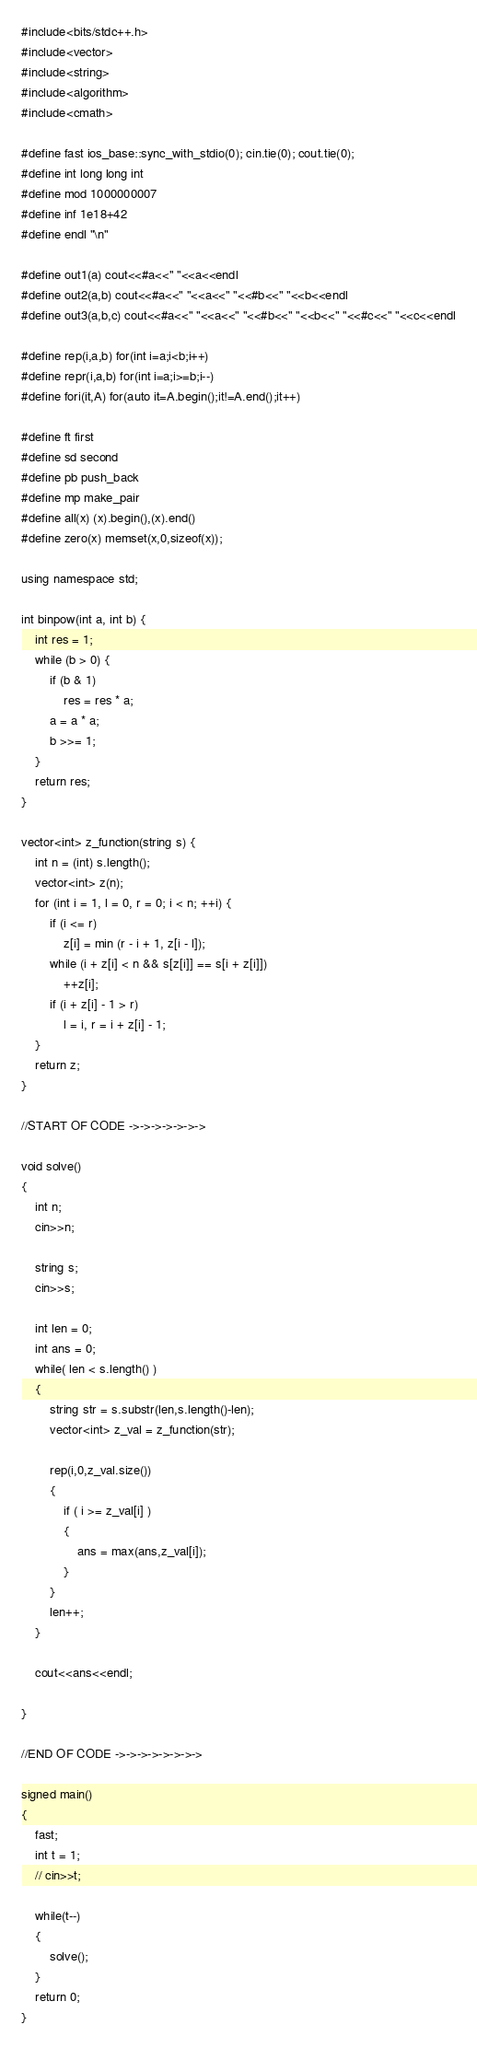<code> <loc_0><loc_0><loc_500><loc_500><_C_>#include<bits/stdc++.h>
#include<vector>
#include<string>
#include<algorithm>
#include<cmath>
 
#define fast ios_base::sync_with_stdio(0); cin.tie(0); cout.tie(0);
#define int long long int
#define mod 1000000007
#define inf 1e18+42
#define endl "\n"

#define out1(a) cout<<#a<<" "<<a<<endl
#define out2(a,b) cout<<#a<<" "<<a<<" "<<#b<<" "<<b<<endl
#define out3(a,b,c) cout<<#a<<" "<<a<<" "<<#b<<" "<<b<<" "<<#c<<" "<<c<<endl

#define rep(i,a,b) for(int i=a;i<b;i++)
#define repr(i,a,b) for(int i=a;i>=b;i--)
#define fori(it,A) for(auto it=A.begin();it!=A.end();it++)

#define ft first
#define sd second
#define pb push_back
#define mp make_pair
#define all(x) (x).begin(),(x).end()
#define zero(x) memset(x,0,sizeof(x));
 
using namespace std;

int binpow(int a, int b) {
    int res = 1;
    while (b > 0) {
        if (b & 1)
            res = res * a;
        a = a * a;
        b >>= 1;
    }
    return res;
}

vector<int> z_function(string s) {
    int n = (int) s.length();
    vector<int> z(n);
    for (int i = 1, l = 0, r = 0; i < n; ++i) {
        if (i <= r)
            z[i] = min (r - i + 1, z[i - l]);
        while (i + z[i] < n && s[z[i]] == s[i + z[i]])
            ++z[i];
        if (i + z[i] - 1 > r)
            l = i, r = i + z[i] - 1;
    }
    return z;
}

//START OF CODE ->->->->->->->

void solve()
{
    int n;
    cin>>n;

    string s;
    cin>>s;

    int len = 0;
    int ans = 0;
    while( len < s.length() )
    {
        string str = s.substr(len,s.length()-len);
        vector<int> z_val = z_function(str);

        rep(i,0,z_val.size())
        {
            if ( i >= z_val[i] )
            {
                ans = max(ans,z_val[i]);
            }
        }
        len++;
    }

    cout<<ans<<endl;

}

//END OF CODE ->->->->->->->->

signed main()
{
    fast;
    int t = 1;
    // cin>>t;

    while(t--)
    {
        solve();
    }
    return 0;
}

</code> 